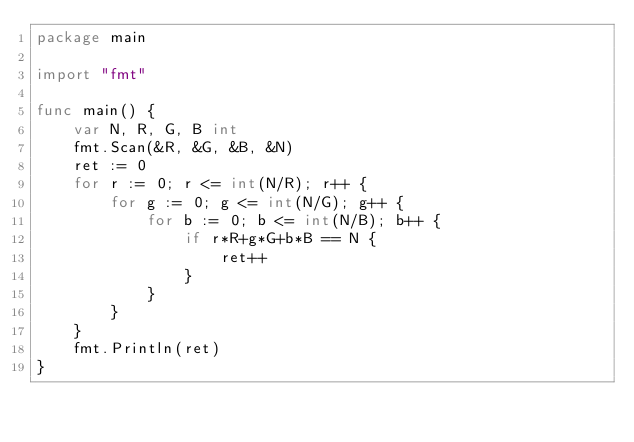<code> <loc_0><loc_0><loc_500><loc_500><_Go_>package main

import "fmt"

func main() {
	var N, R, G, B int
	fmt.Scan(&R, &G, &B, &N)
	ret := 0
	for r := 0; r <= int(N/R); r++ {
		for g := 0; g <= int(N/G); g++ {
			for b := 0; b <= int(N/B); b++ {
				if r*R+g*G+b*B == N {
					ret++
				}
			}
		}
	}
	fmt.Println(ret)
}
</code> 